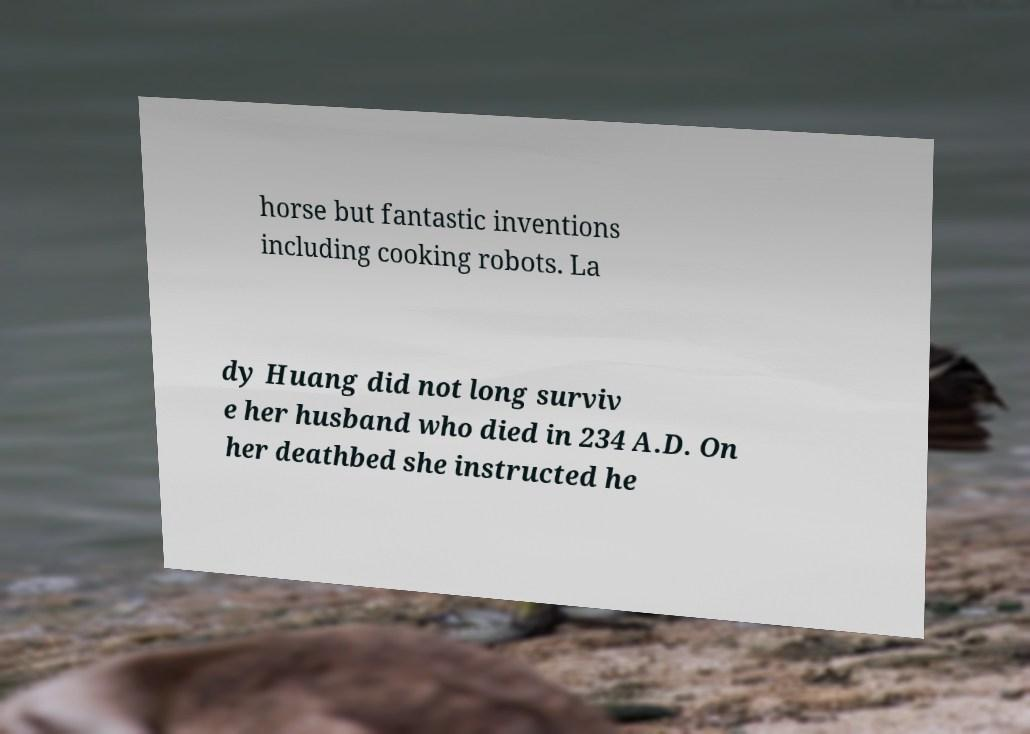Could you assist in decoding the text presented in this image and type it out clearly? horse but fantastic inventions including cooking robots. La dy Huang did not long surviv e her husband who died in 234 A.D. On her deathbed she instructed he 